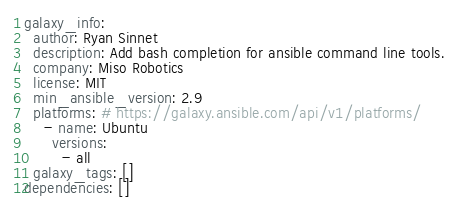Convert code to text. <code><loc_0><loc_0><loc_500><loc_500><_YAML_>galaxy_info:
  author: Ryan Sinnet
  description: Add bash completion for ansible command line tools.
  company: Miso Robotics
  license: MIT
  min_ansible_version: 2.9
  platforms: # https://galaxy.ansible.com/api/v1/platforms/
    - name: Ubuntu
      versions:
        - all
  galaxy_tags: []
dependencies: []
</code> 